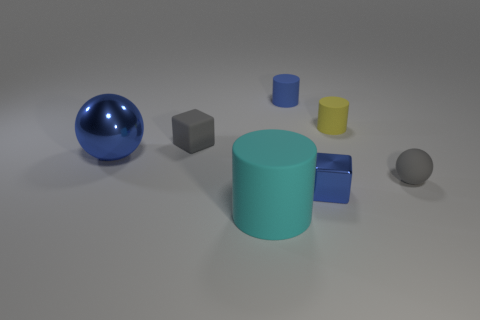Subtract all blue matte cylinders. How many cylinders are left? 2 Add 3 red metallic cubes. How many objects exist? 10 Add 4 tiny cylinders. How many tiny cylinders are left? 6 Add 5 small purple shiny spheres. How many small purple shiny spheres exist? 5 Subtract all gray spheres. How many spheres are left? 1 Subtract 0 red spheres. How many objects are left? 7 Subtract all cubes. How many objects are left? 5 Subtract 1 blocks. How many blocks are left? 1 Subtract all blue blocks. Subtract all purple balls. How many blocks are left? 1 Subtract all purple cubes. How many gray spheres are left? 1 